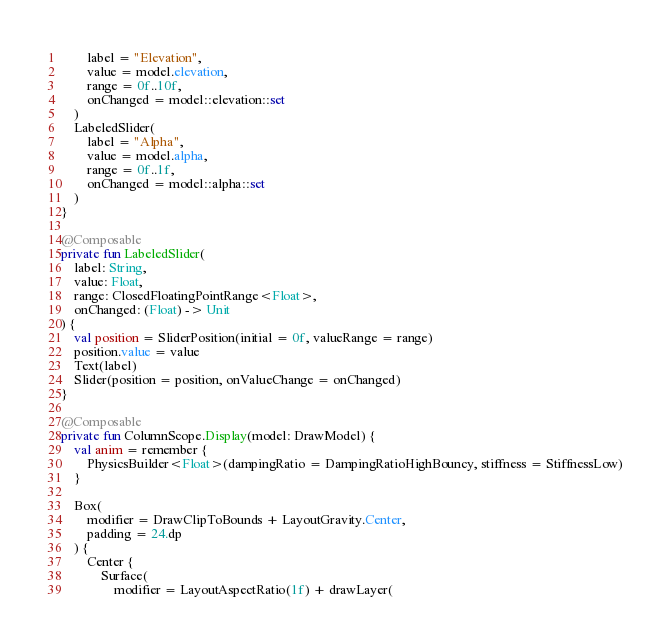<code> <loc_0><loc_0><loc_500><loc_500><_Kotlin_>        label = "Elevation",
        value = model.elevation,
        range = 0f..10f,
        onChanged = model::elevation::set
    )
    LabeledSlider(
        label = "Alpha",
        value = model.alpha,
        range = 0f..1f,
        onChanged = model::alpha::set
    )
}

@Composable
private fun LabeledSlider(
    label: String,
    value: Float,
    range: ClosedFloatingPointRange<Float>,
    onChanged: (Float) -> Unit
) {
    val position = SliderPosition(initial = 0f, valueRange = range)
    position.value = value
    Text(label)
    Slider(position = position, onValueChange = onChanged)
}

@Composable
private fun ColumnScope.Display(model: DrawModel) {
    val anim = remember {
        PhysicsBuilder<Float>(dampingRatio = DampingRatioHighBouncy, stiffness = StiffnessLow)
    }

    Box(
        modifier = DrawClipToBounds + LayoutGravity.Center,
        padding = 24.dp
    ) {
        Center {
            Surface(
                modifier = LayoutAspectRatio(1f) + drawLayer(</code> 